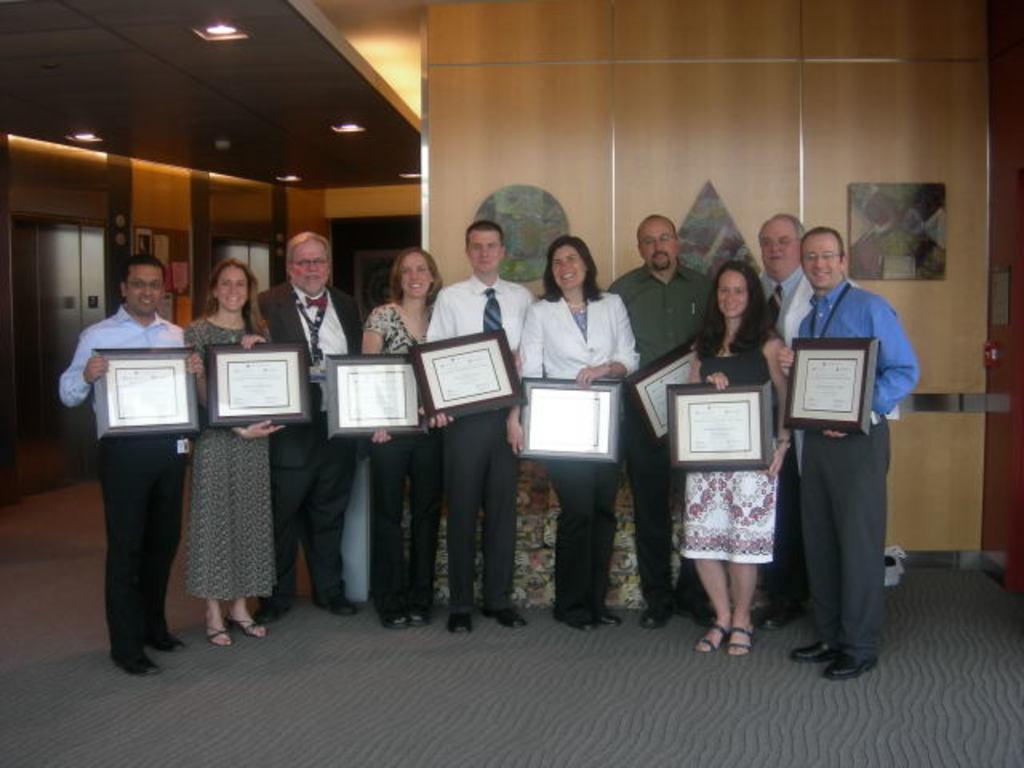Please provide a concise description of this image. In this picture I can observe some people standing on the floor holding frames in their hands. All of them are smiling. They are men and women in this picture. In the background there is a wall. 